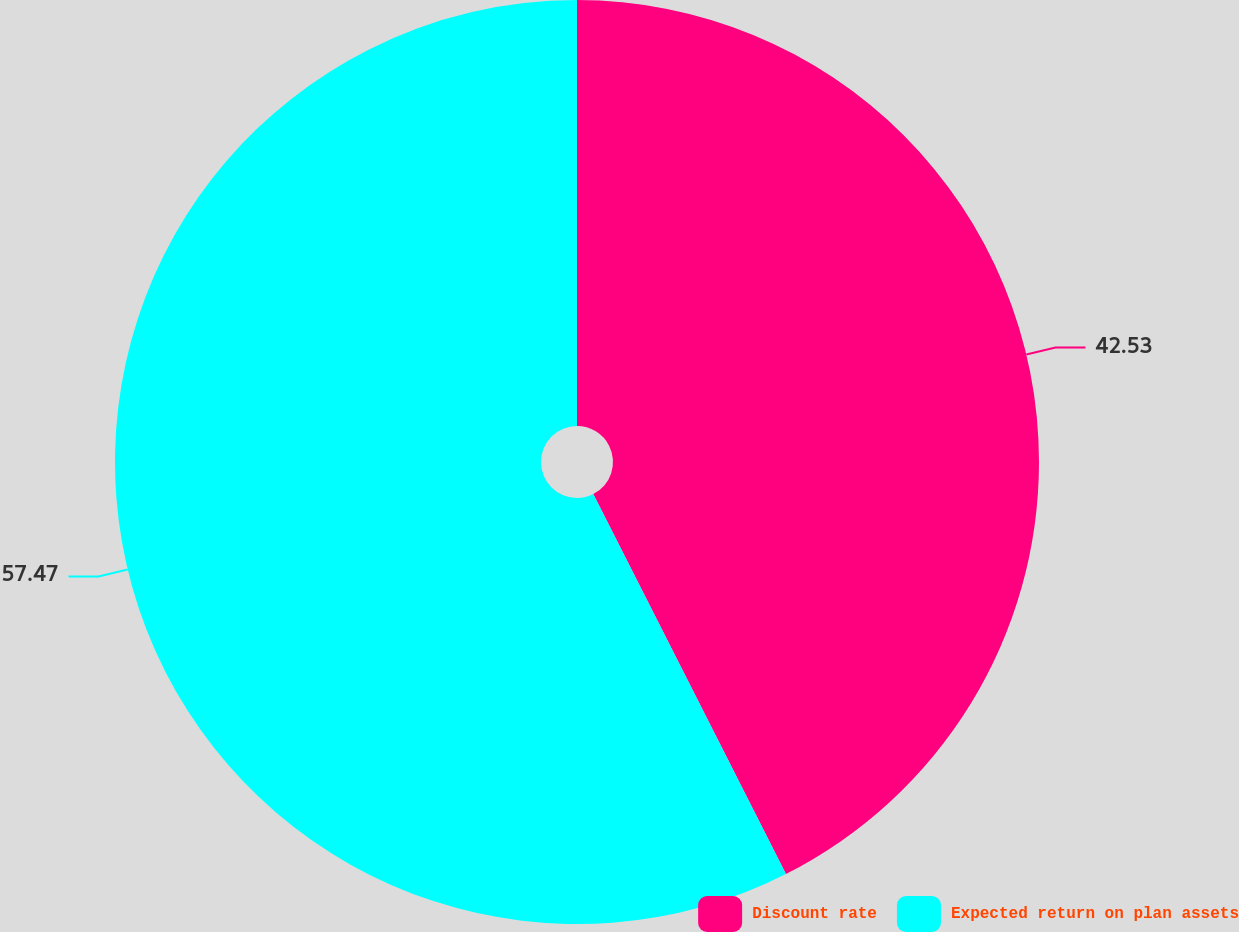Convert chart to OTSL. <chart><loc_0><loc_0><loc_500><loc_500><pie_chart><fcel>Discount rate<fcel>Expected return on plan assets<nl><fcel>42.53%<fcel>57.47%<nl></chart> 